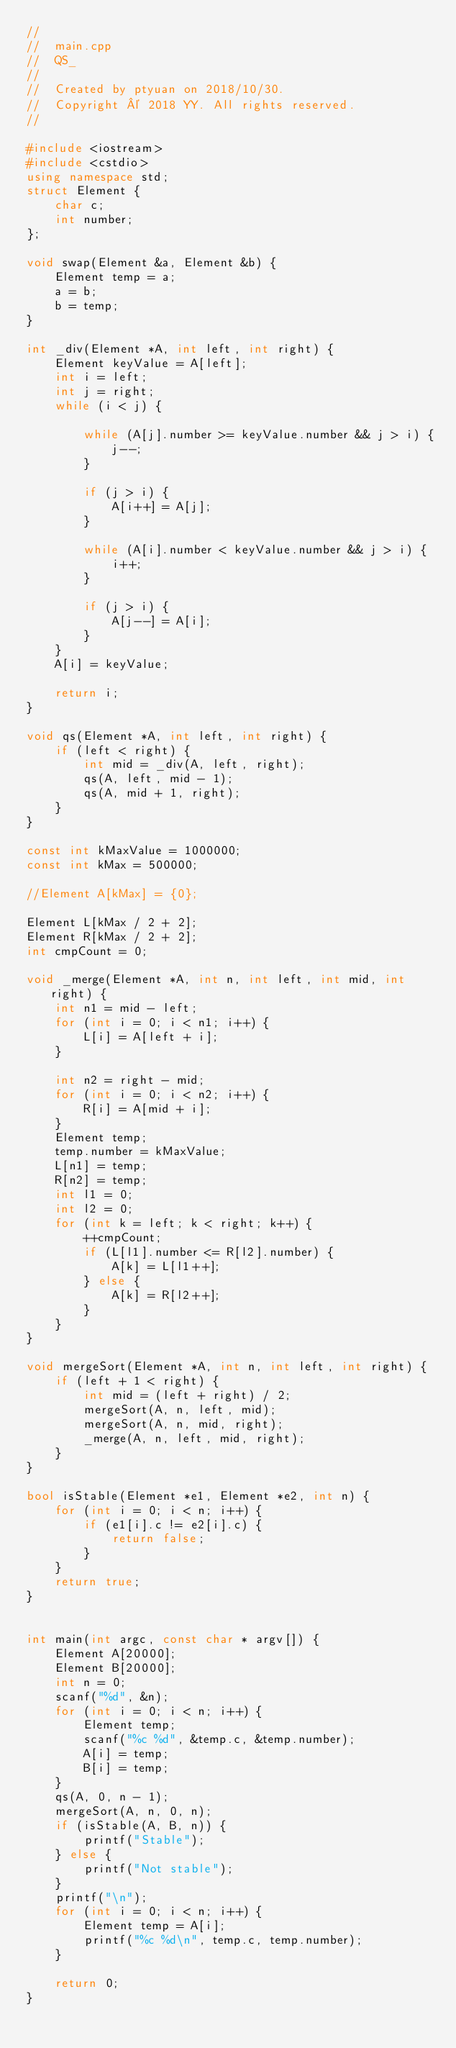<code> <loc_0><loc_0><loc_500><loc_500><_C++_>//
//  main.cpp
//  QS_
//
//  Created by ptyuan on 2018/10/30.
//  Copyright © 2018 YY. All rights reserved.
//

#include <iostream>
#include <cstdio>
using namespace std;
struct Element {
    char c;
    int number;
};

void swap(Element &a, Element &b) {
    Element temp = a;
    a = b;
    b = temp;
}

int _div(Element *A, int left, int right) {
    Element keyValue = A[left];
    int i = left;
    int j = right;
    while (i < j) {
        
        while (A[j].number >= keyValue.number && j > i) {
            j--;
        }
        
        if (j > i) {
            A[i++] = A[j];
        }
        
        while (A[i].number < keyValue.number && j > i) {
            i++;
        }
        
        if (j > i) {
            A[j--] = A[i];
        }
    }
    A[i] = keyValue;
    
    return i;
}

void qs(Element *A, int left, int right) {
    if (left < right) {
        int mid = _div(A, left, right);
        qs(A, left, mid - 1);
        qs(A, mid + 1, right);
    }
}

const int kMaxValue = 1000000;
const int kMax = 500000;

//Element A[kMax] = {0};

Element L[kMax / 2 + 2];
Element R[kMax / 2 + 2];
int cmpCount = 0;

void _merge(Element *A, int n, int left, int mid, int right) {
    int n1 = mid - left;
    for (int i = 0; i < n1; i++) {
        L[i] = A[left + i];
    }
    
    int n2 = right - mid;
    for (int i = 0; i < n2; i++) {
        R[i] = A[mid + i];
    }
    Element temp;
    temp.number = kMaxValue;
    L[n1] = temp;
    R[n2] = temp;
    int l1 = 0;
    int l2 = 0;
    for (int k = left; k < right; k++) {
        ++cmpCount;
        if (L[l1].number <= R[l2].number) {
            A[k] = L[l1++];
        } else {
            A[k] = R[l2++];
        }
    }
}

void mergeSort(Element *A, int n, int left, int right) {
    if (left + 1 < right) {
        int mid = (left + right) / 2;
        mergeSort(A, n, left, mid);
        mergeSort(A, n, mid, right);
        _merge(A, n, left, mid, right);
    }
}

bool isStable(Element *e1, Element *e2, int n) {
    for (int i = 0; i < n; i++) {
        if (e1[i].c != e2[i].c) {
            return false;
        }
    }
    return true;
}


int main(int argc, const char * argv[]) {
    Element A[20000];
    Element B[20000];
    int n = 0;
    scanf("%d", &n);
    for (int i = 0; i < n; i++) {
        Element temp;
        scanf("%c %d", &temp.c, &temp.number);
        A[i] = temp;
        B[i] = temp;
    }
    qs(A, 0, n - 1);
    mergeSort(A, n, 0, n);
    if (isStable(A, B, n)) {
        printf("Stable");
    } else {
        printf("Not stable");
    }
    printf("\n");
    for (int i = 0; i < n; i++) {
        Element temp = A[i];
        printf("%c %d\n", temp.c, temp.number);
    }
    
    return 0;
}


</code> 